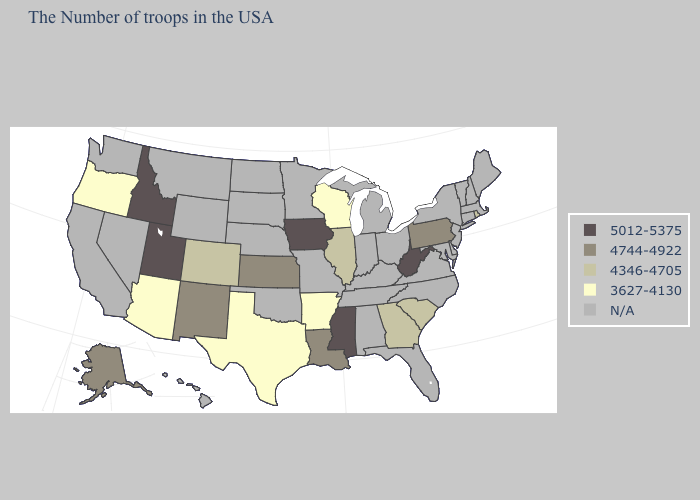Name the states that have a value in the range 5012-5375?
Write a very short answer. West Virginia, Mississippi, Iowa, Utah, Idaho. What is the value of North Carolina?
Answer briefly. N/A. Which states hav the highest value in the South?
Give a very brief answer. West Virginia, Mississippi. What is the lowest value in the USA?
Concise answer only. 3627-4130. Among the states that border New Mexico , which have the highest value?
Write a very short answer. Utah. What is the value of Massachusetts?
Give a very brief answer. N/A. Which states have the highest value in the USA?
Write a very short answer. West Virginia, Mississippi, Iowa, Utah, Idaho. Which states have the highest value in the USA?
Write a very short answer. West Virginia, Mississippi, Iowa, Utah, Idaho. Does the first symbol in the legend represent the smallest category?
Give a very brief answer. No. What is the lowest value in states that border Ohio?
Short answer required. 4744-4922. What is the lowest value in the West?
Concise answer only. 3627-4130. What is the highest value in the USA?
Answer briefly. 5012-5375. Among the states that border Maryland , which have the highest value?
Be succinct. West Virginia. Name the states that have a value in the range N/A?
Quick response, please. Maine, Massachusetts, New Hampshire, Vermont, Connecticut, New York, New Jersey, Delaware, Maryland, Virginia, North Carolina, Ohio, Florida, Michigan, Kentucky, Indiana, Alabama, Tennessee, Missouri, Minnesota, Nebraska, Oklahoma, South Dakota, North Dakota, Wyoming, Montana, Nevada, California, Washington, Hawaii. 